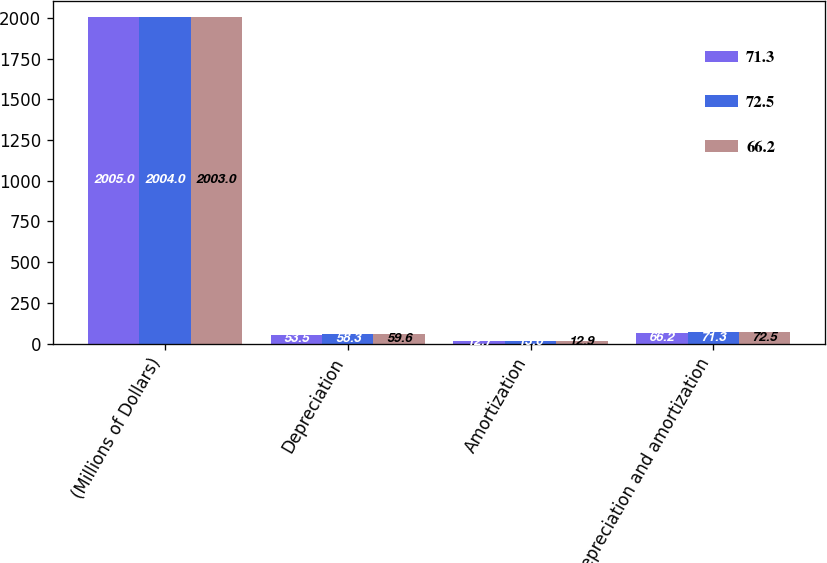Convert chart to OTSL. <chart><loc_0><loc_0><loc_500><loc_500><stacked_bar_chart><ecel><fcel>(Millions of Dollars)<fcel>Depreciation<fcel>Amortization<fcel>Depreciation and amortization<nl><fcel>71.3<fcel>2005<fcel>53.5<fcel>12.7<fcel>66.2<nl><fcel>72.5<fcel>2004<fcel>58.3<fcel>13<fcel>71.3<nl><fcel>66.2<fcel>2003<fcel>59.6<fcel>12.9<fcel>72.5<nl></chart> 